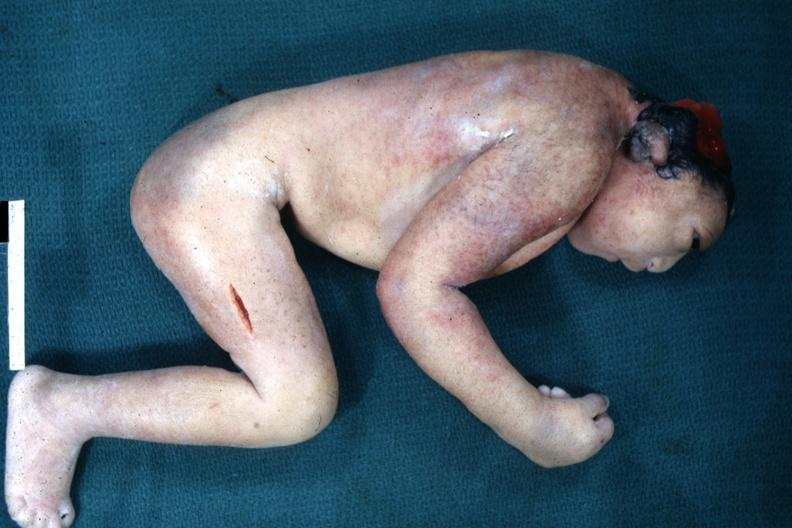what is present?
Answer the question using a single word or phrase. Anencephaly 